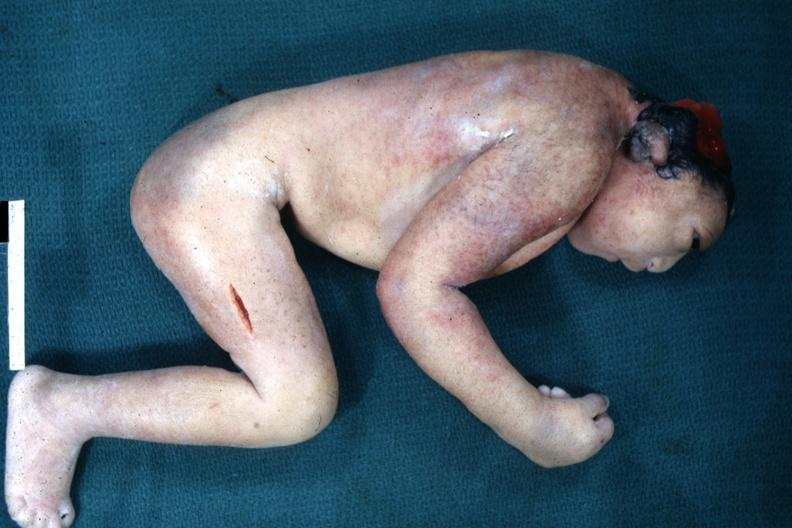what is present?
Answer the question using a single word or phrase. Anencephaly 